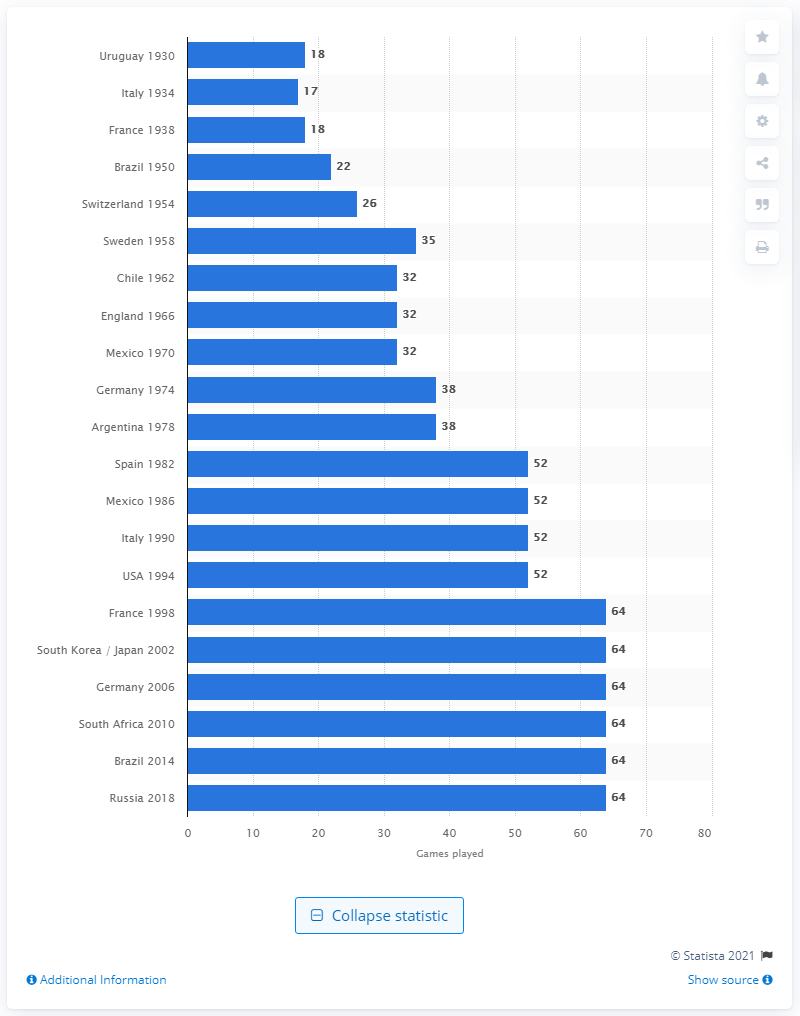Point out several critical features in this image. The latest World Cup in Russia featured 64 games. 